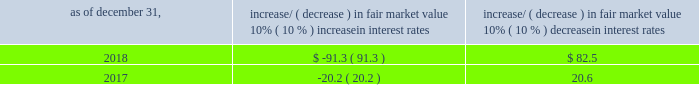Item 7a .
Quantitative and qualitative disclosures about market risk ( amounts in millions ) in the normal course of business , we are exposed to market risks related to interest rates , foreign currency rates and certain balance sheet items .
From time to time , we use derivative instruments , pursuant to established guidelines and policies , to manage some portion of these risks .
Derivative instruments utilized in our hedging activities are viewed as risk management tools and are not used for trading or speculative purposes .
Interest rates our exposure to market risk for changes in interest rates relates primarily to the fair market value and cash flows of our debt obligations .
The majority of our debt ( approximately 86% ( 86 % ) and 94% ( 94 % ) as of december 31 , 2018 and 2017 , respectively ) bears interest at fixed rates .
We do have debt with variable interest rates , but a 10% ( 10 % ) increase or decrease in interest rates would not be material to our interest expense or cash flows .
The fair market value of our debt is sensitive to changes in interest rates , and the impact of a 10% ( 10 % ) change in interest rates is summarized below .
Increase/ ( decrease ) in fair market value as of december 31 , 10% ( 10 % ) increase in interest rates 10% ( 10 % ) decrease in interest rates .
We have used interest rate swaps for risk management purposes to manage our exposure to changes in interest rates .
We did not have any interest rate swaps outstanding as of december 31 , 2018 .
We had $ 673.5 of cash , cash equivalents and marketable securities as of december 31 , 2018 that we generally invest in conservative , short-term bank deposits or securities .
The interest income generated from these investments is subject to both domestic and foreign interest rate movements .
During 2018 and 2017 , we had interest income of $ 21.8 and $ 19.4 , respectively .
Based on our 2018 results , a 100 basis-point increase or decrease in interest rates would affect our interest income by approximately $ 6.7 , assuming that all cash , cash equivalents and marketable securities are impacted in the same manner and balances remain constant from year-end 2018 levels .
Foreign currency rates we are subject to translation and transaction risks related to changes in foreign currency exchange rates .
Since we report revenues and expenses in u.s .
Dollars , changes in exchange rates may either positively or negatively affect our consolidated revenues and expenses ( as expressed in u.s .
Dollars ) from foreign operations .
The foreign currencies that most favorably impacted our results during the year ended december 31 , 2018 were the euro and british pound sterling .
The foreign currencies that most adversely impacted our results during the year ended december 31 , of 2018 were the argentine peso and brazilian real .
Based on 2018 exchange rates and operating results , if the u.s .
Dollar were to strengthen or weaken by 10% ( 10 % ) , we currently estimate operating income would decrease or increase approximately 4% ( 4 % ) , assuming that all currencies are impacted in the same manner and our international revenue and expenses remain constant at 2018 levels .
The functional currency of our foreign operations is generally their respective local currency .
Assets and liabilities are translated at the exchange rates in effect at the balance sheet date , and revenues and expenses are translated at the average exchange rates during the period presented .
The resulting translation adjustments are recorded as a component of accumulated other comprehensive loss , net of tax , in the stockholders 2019 equity section of our consolidated balance sheets .
Our foreign subsidiaries generally collect revenues and pay expenses in their functional currency , mitigating transaction risk .
However , certain subsidiaries may enter into transactions in currencies other than their functional currency .
Assets and liabilities denominated in currencies other than the functional currency are susceptible to movements in foreign currency until final settlement .
Currency transaction gains or losses primarily arising from transactions in currencies other than the functional currency are included in office and general expenses .
We regularly review our foreign exchange exposures that may have a material impact on our business and from time to time use foreign currency forward exchange contracts or other .
During 2017 and 2018 , what was the average interest income , in millions? 
Computations: ((21.8 + 19.4) / 2)
Answer: 20.6. 